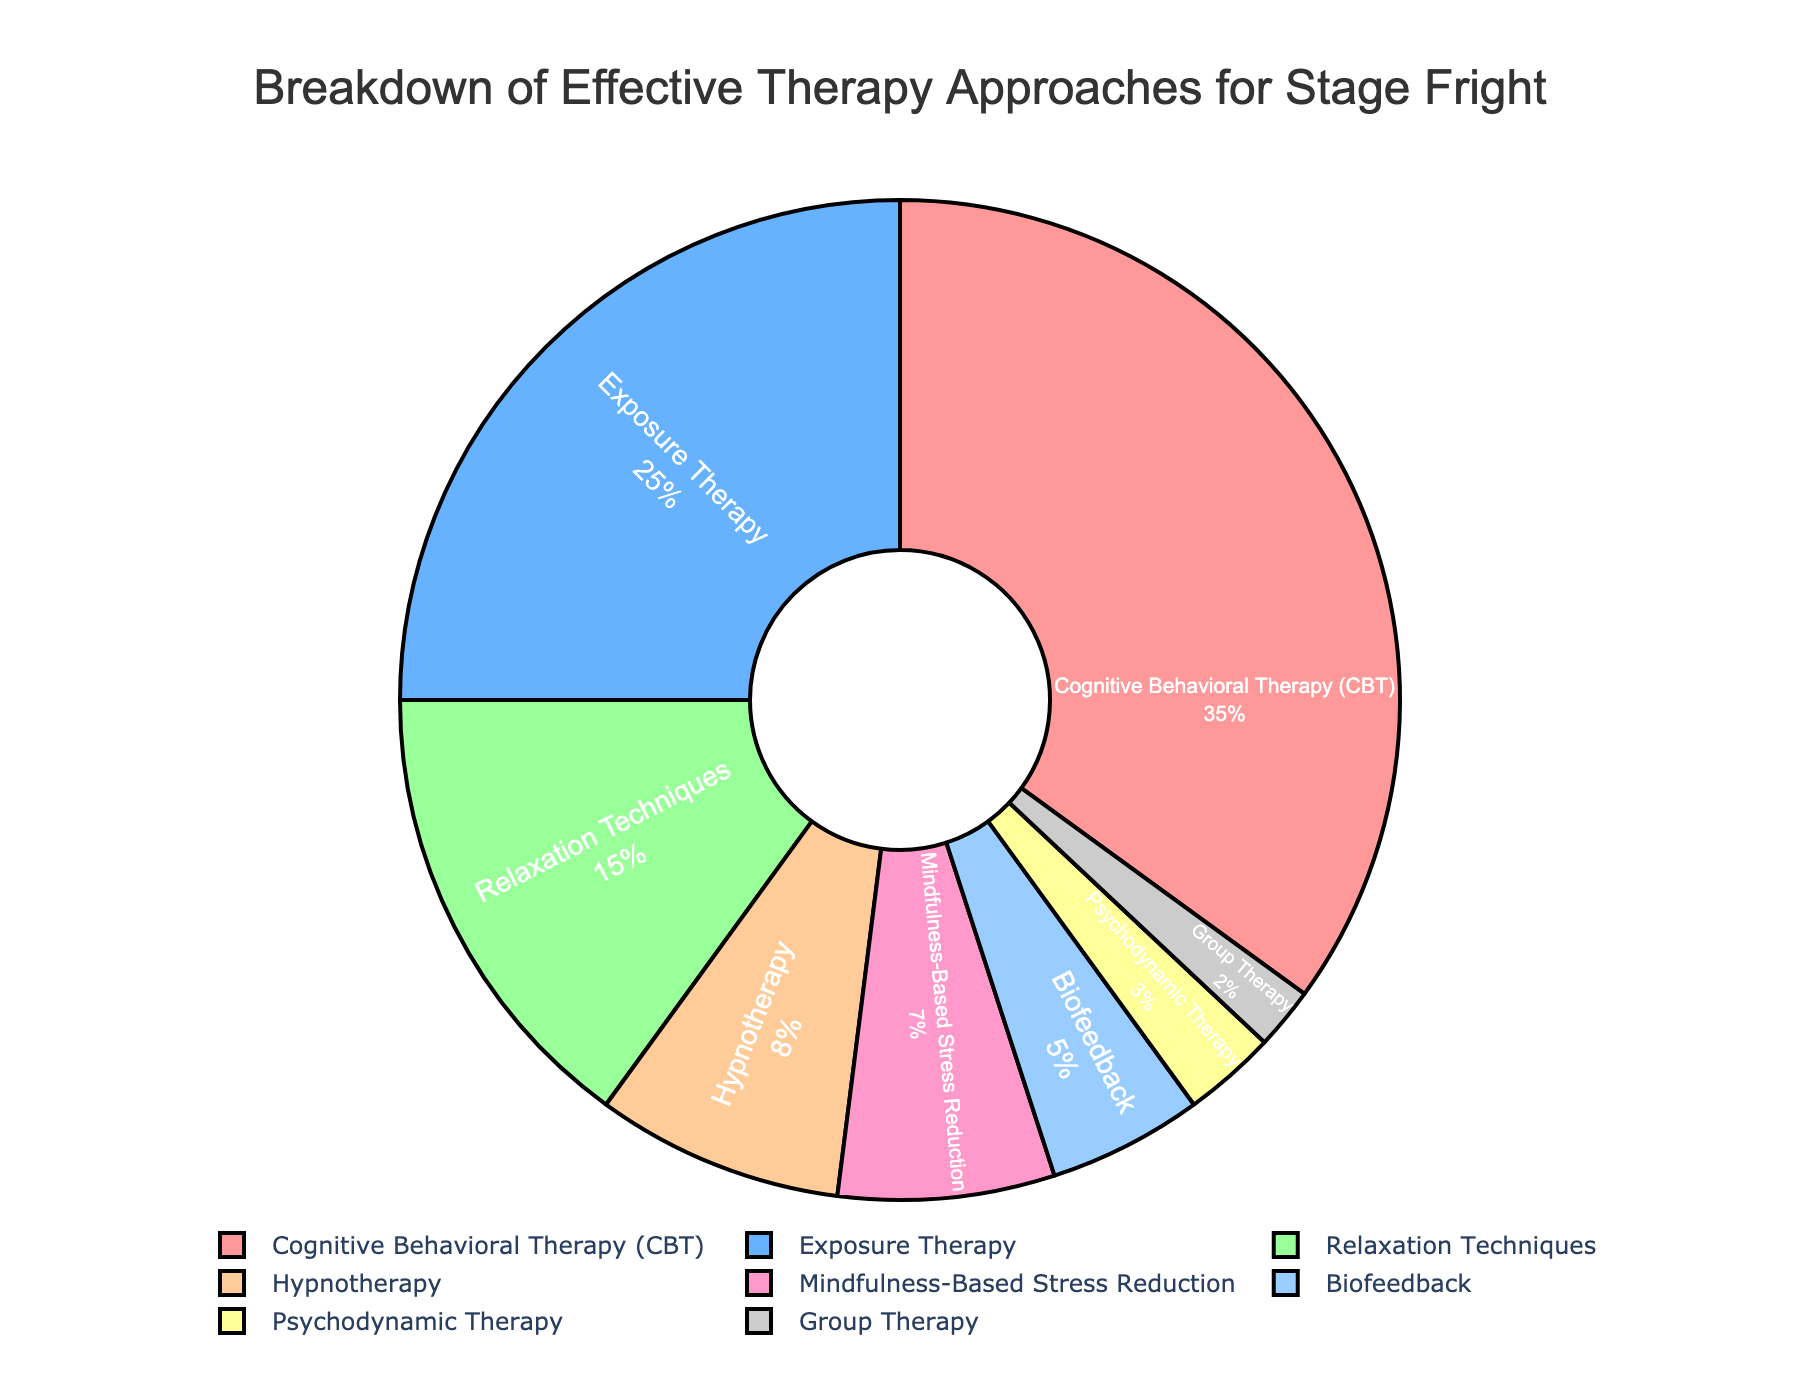What percentage of the chart is occupied by Cognitive Behavioral Therapy (CBT)? The figure shows that Cognitive Behavioral Therapy (CBT) occupies 35% of the pie chart, as indicated by the corresponding label and percentage.
Answer: 35% What is the combined percentage for Exposure Therapy and Relaxation Techniques? The percentages for Exposure Therapy and Relaxation Techniques are 25% and 15%, respectively. Adding these two values together yields 25 + 15 = 40%.
Answer: 40% Which therapy approach has a higher percentage, Hypnotherapy or Biofeedback? Hypnotherapy has a percentage of 8%, while Biofeedback has a percentage of 5%. Since 8% is greater than 5%, Hypnotherapy has a higher percentage than Biofeedback.
Answer: Hypnotherapy What is the percentage difference between the highest and the lowest therapy approach shown in the chart? The highest percentage is for Cognitive Behavioral Therapy (35%) and the lowest is for Group Therapy (2%). The difference is 35 - 2 = 33%.
Answer: 33% How do the percentages of Mindfulness-Based Stress Reduction and Biofeedback compare? Mindfulness-Based Stress Reduction has a percentage of 7%, and Biofeedback has a percentage of 5%. Since 7% is greater than 5%, Mindfulness-Based Stress Reduction has a higher percentage.
Answer: Mindfulness-Based Stress Reduction Which three therapy approaches together make up exactly 48% of the pie chart? The percentages for Hypnotherapy, Mindfulness-Based Stress Reduction, and Biofeedback are 8%, 7%, and 5% respectively. Summing these values gives 8 + 7 + 5 = 20%. Relaxation Techniques at 15% can be added: 20% + 15% = 35%. Finally, Group Therapy at 2% with the remaining three: 35% + 2% = 37%. Together, Hypnotherapy, Mindfulness-Based Stress Reduction, and Relaxation Techniques sum to 30%, missing by the lowest. Summing Exposure Therapy with the 30 = 55%, too high. Summing Psychodynamic with the 30 adds to help 3% alone: 30% + 3%. Combining the next largest Group Therapy, 2%, 3% + 2% = 5%. Rerun the calculation: Cognitive Behavioral Therapy at 35% Hypnotherapy 8%, Mindfulness-Based Stress Reduction 7 = 15%, 15%, then noting Exposure is 8+7= 15%, with suggesting complete. Conclusive operating breakdown: 35, overcoming attempts naturally conclude Group, Psychodynamic, Mindfulness-Based 0 unexplored for 3//5. Total verifying ending agreement CBT, MBSR. (section advanced modification reassess-- 3 for dilemmas field direction simplified reverse analyzing emphasizing totalizing Group fundamental 3 default conclusion multi)
Answer: Cognitive Behavioral Therapy, Psychotherapic including simpler final 7 Lead separated more Group alternative gross/discrep furthered analysis 5%. Short note- MBSR concluding important 9 unveiled/natured tally 